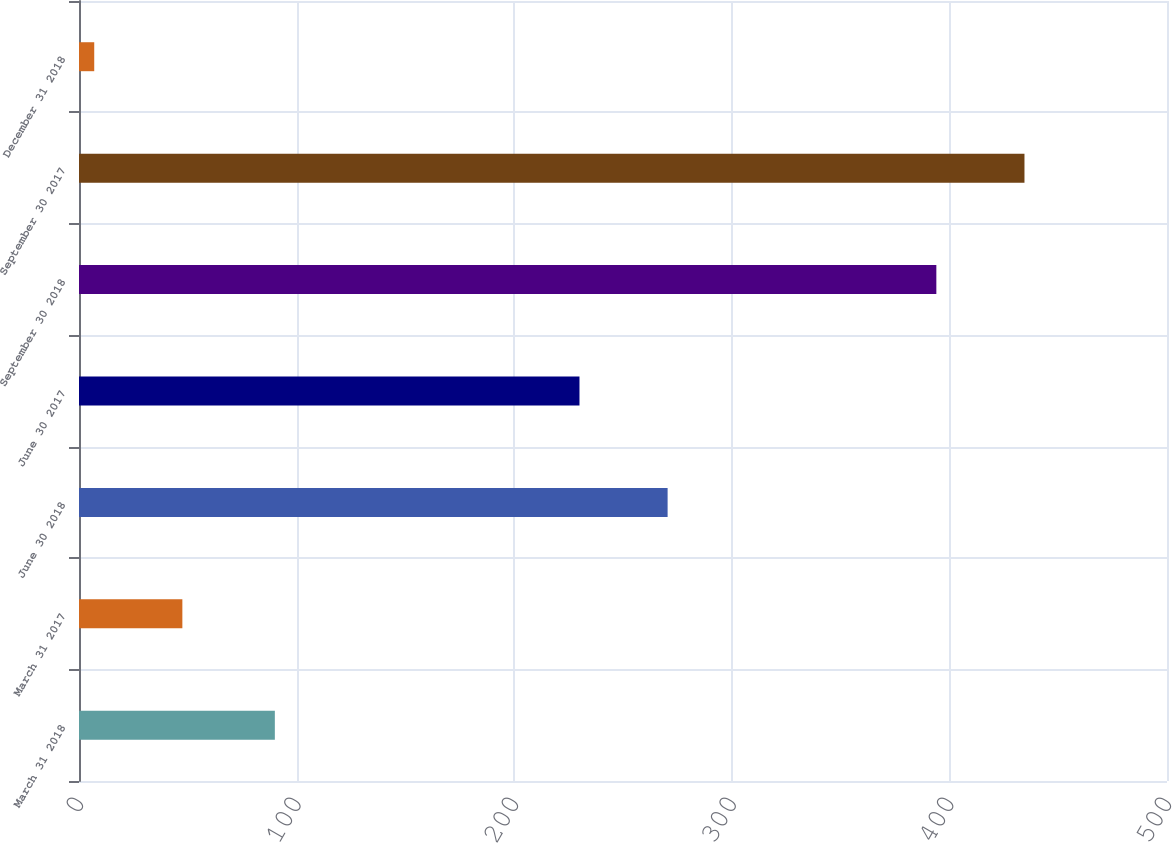Convert chart to OTSL. <chart><loc_0><loc_0><loc_500><loc_500><bar_chart><fcel>March 31 2018<fcel>March 31 2017<fcel>June 30 2018<fcel>June 30 2017<fcel>September 30 2018<fcel>September 30 2017<fcel>December 31 2018<nl><fcel>90<fcel>47.5<fcel>270.5<fcel>230<fcel>394<fcel>434.5<fcel>7<nl></chart> 